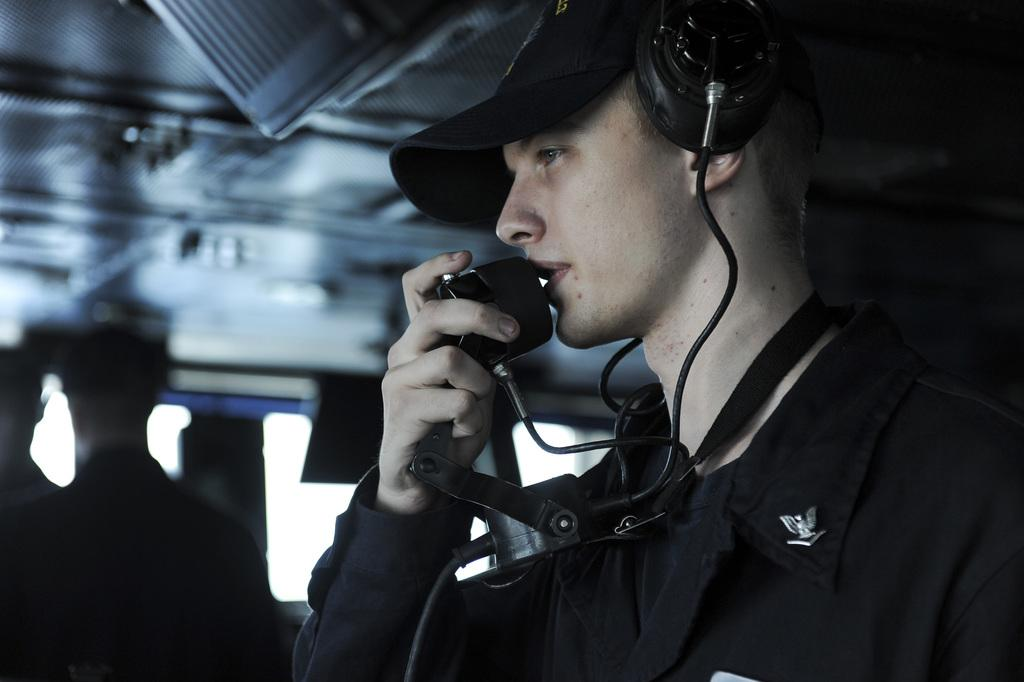What is the main subject of the image? There is a person in the image. What is the person doing in the image? The person is standing in the image. What object is the person holding in his hand? The person is holding a mic in his hand. What type of headwear is the person wearing? The person is wearing a cap on his head. What can be seen at the top of the image? There is a roof visible at the top of the image. Where is the person's grandmother sitting in the image? There is no grandmother present in the image. What type of yoke is the person using to carry the mic in the image? There is no yoke present in the image; the person is simply holding the mic in his hand. 